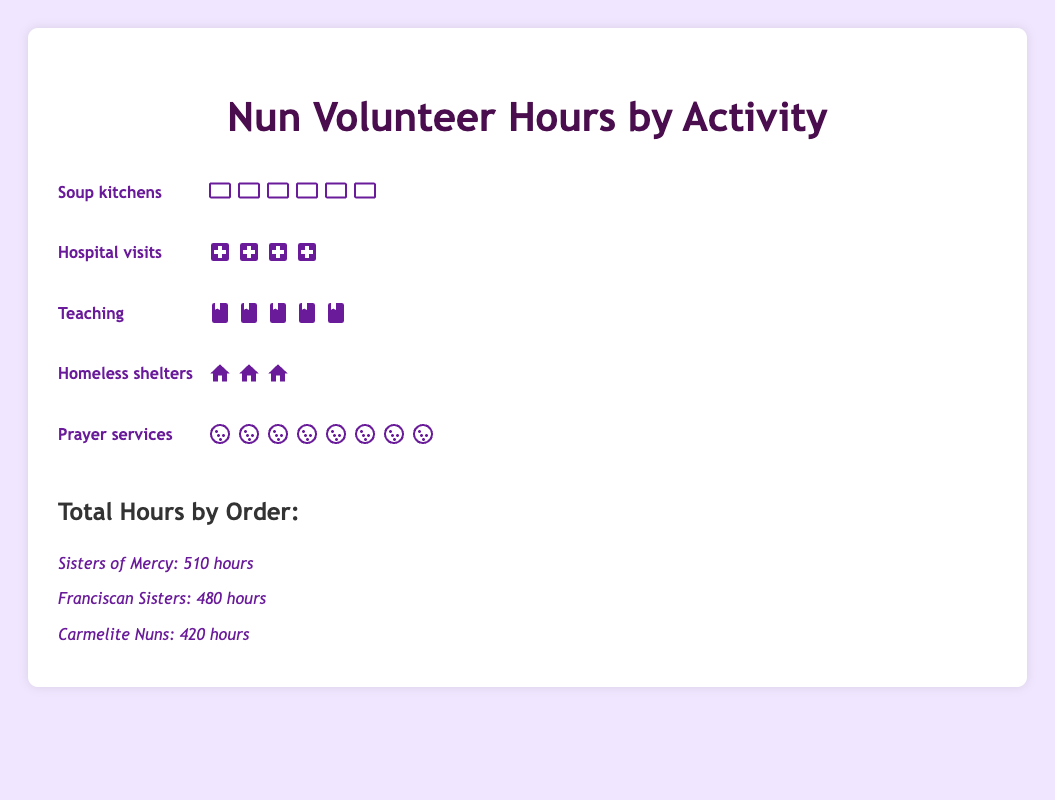What activity has the most volunteer hours? The plot shows various activities with different icon types representing hours spent. The activity with the most icons is "Prayer services," which has the most volunteer hours.
Answer: Prayer services Which activity has the least volunteer hours? By observing the plot, each activity has a corresponding number of icons. The activity with the fewest icons is "Homeless shelters," indicating the least volunteer hours.
Answer: Homeless shelters How many more hours are spent in Prayer services compared to Soup kitchens? Prayer services have 150 hours, represented by 8 prayer bead icons, while Soup kitchens have 120 hours, represented by 6 bowl icons. The difference is calculated as 150 - 120.
Answer: 30 hours If a nun wants to balance her time equally among all activities, how many hours should she spend on each? Summing all volunteer hours from each activity: 120 (Soup kitchens) + 80 (Hospital visits) + 100 (Teaching) + 60 (Homeless shelters) + 150 (Prayer services) equals 510 hours. Dividing 510 by 5 gives an equal distribution.
Answer: 102 hours Which order has the highest number of volunteer hours? The section listing total hours by order shows that "Sisters of Mercy" has 510 hours, which is the highest among the orders.
Answer: Sisters of Mercy By how much do the total hours of Sisters of Mercy exceed those of Carmelite Nuns? The total hours for Sisters of Mercy are 510, and for Carmelite Nuns are 420. Subtracting 420 from 510 gives the difference.
Answer: 90 hours Do Teaching and Homeless shelters combined have more hours than Hospital visits alone? Teaching has 100 hours and Homeless shelters have 60 hours. Combined, they sum to 100 + 60 = 160 hours. Hospital visits alone have 80 hours. Compared together, 160 is more than 80.
Answer: Yes How many icons in total represent the Soup kitchens activity? Each bowl icon represents 20 hours. With 120 hours spent on Soup kitchens, dividing 120 by 20 gives the total number of icons.
Answer: 6 icons Which activity constitutes the smallest portion of volunteer hours? Homeless shelters with 60 hours have the fewest icons, indicating the smallest portion.
Answer: Homeless shelters Which two activities have hours that sum closest to 200? Soup kitchens (120 hours) and Hospital visits (80 hours) sum to 200 hours; this pair is closer to 200 than any other combination.
Answer: Soup kitchens and Hospital visits 